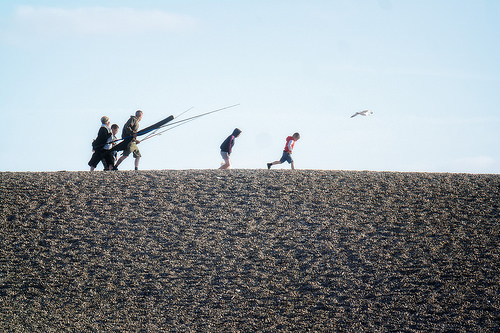<image>
Can you confirm if the shirt is on the man? No. The shirt is not positioned on the man. They may be near each other, but the shirt is not supported by or resting on top of the man. 